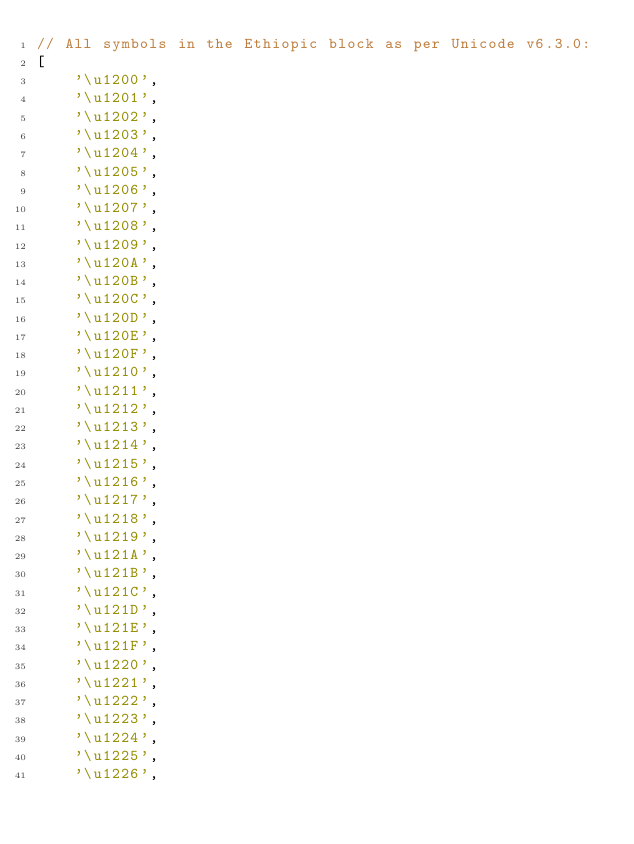<code> <loc_0><loc_0><loc_500><loc_500><_JavaScript_>// All symbols in the Ethiopic block as per Unicode v6.3.0:
[
	'\u1200',
	'\u1201',
	'\u1202',
	'\u1203',
	'\u1204',
	'\u1205',
	'\u1206',
	'\u1207',
	'\u1208',
	'\u1209',
	'\u120A',
	'\u120B',
	'\u120C',
	'\u120D',
	'\u120E',
	'\u120F',
	'\u1210',
	'\u1211',
	'\u1212',
	'\u1213',
	'\u1214',
	'\u1215',
	'\u1216',
	'\u1217',
	'\u1218',
	'\u1219',
	'\u121A',
	'\u121B',
	'\u121C',
	'\u121D',
	'\u121E',
	'\u121F',
	'\u1220',
	'\u1221',
	'\u1222',
	'\u1223',
	'\u1224',
	'\u1225',
	'\u1226',</code> 